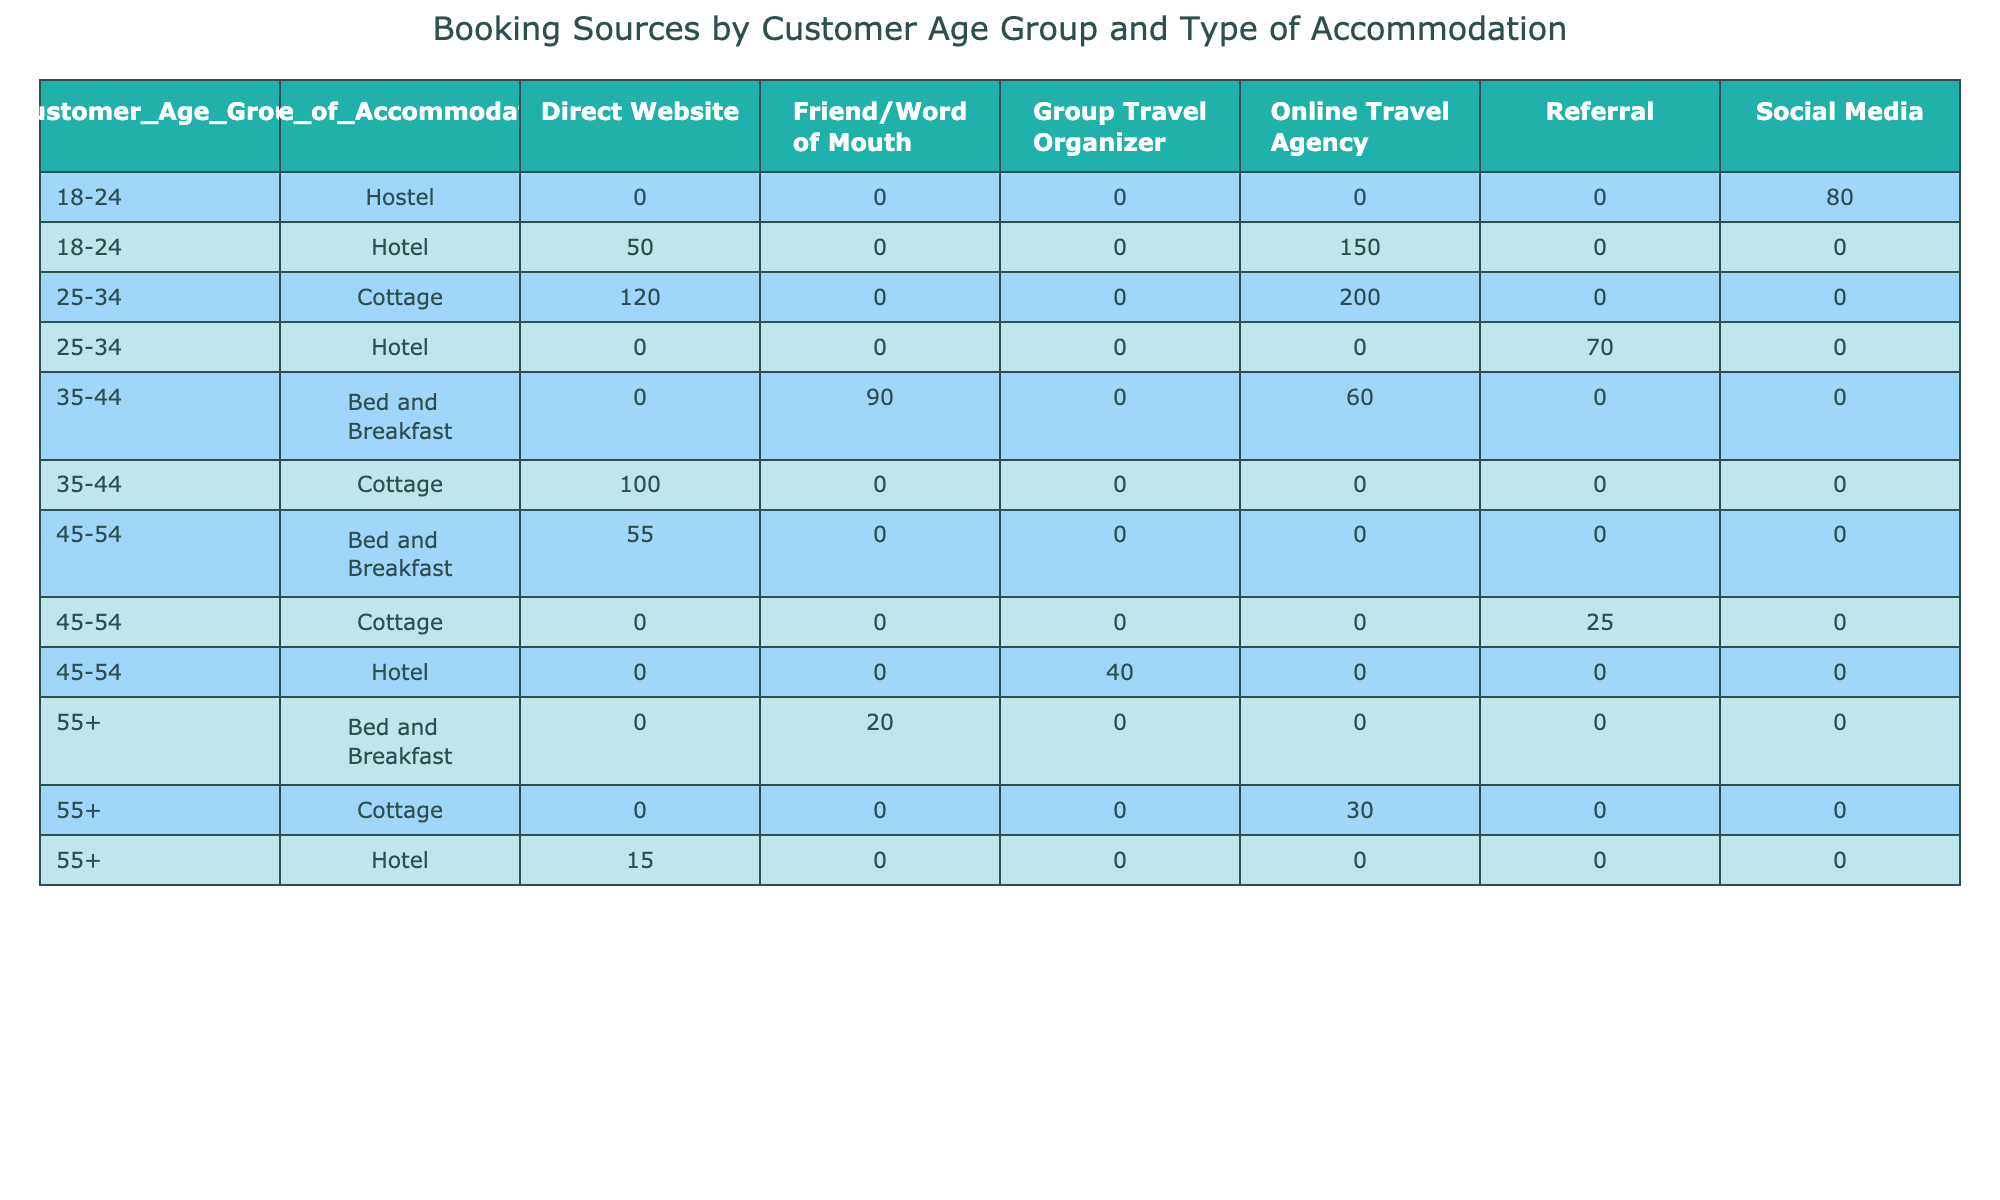What is the total number of bookings for the age group 25-34 staying in cottages? In the table, the number of bookings for the age group 25-34 staying in cottages is listed under the "Cottage" row with the "Booking Source". The direct website has 120 bookings and the online travel agency has 200 bookings. Adding these together gives 120 + 200 = 320 bookings.
Answer: 320 Which booking source had the highest number of bookings for the age group 18-24? Looking at the age group 18-24, the bookings from each source are: Online Travel Agency (150), Direct Website (50), and Social Media (80). The highest value among these is the Online Travel Agency with 150 bookings.
Answer: Online Travel Agency Is there any age group that does not use the Referral booking source? To determine this, we examine each age group for the presence of the Referral booking source. The age groups 18-24, 35-44, and 55+ do not have any entry for Referral. Therefore, we can conclude that yes, there are age groups without this source.
Answer: Yes What is the average number of bookings for the "Bed and Breakfast" accommodation type across all age groups? For "Bed and Breakfast", the bookings are: 90 from Friend/Word of Mouth (for age 35-44) + 20 from Friend/Word of Mouth (for age 55+) + 55 from Direct Website (for age 45-54). To find the average, we sum these values: 90 + 20 + 55 = 165. There are 3 entries, so the average is 165 / 3 = 55.
Answer: 55 Which age group had the least number of bookings for hotels? Examining the Hotel bookings for each age group: 150 for 18-24, 70 for 25-34, and 40 for 45-54, and 15 for 55+. The lowest number is for the age group 55+, which had only 15 bookings.
Answer: 55+ 